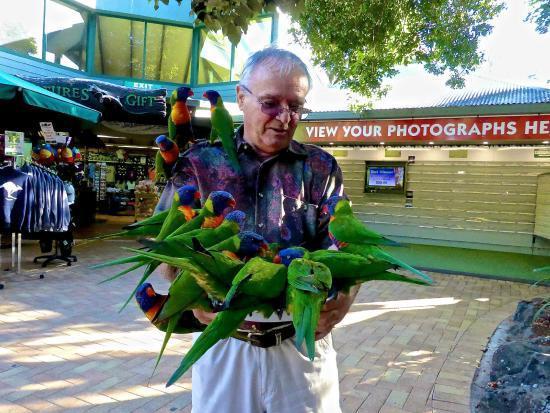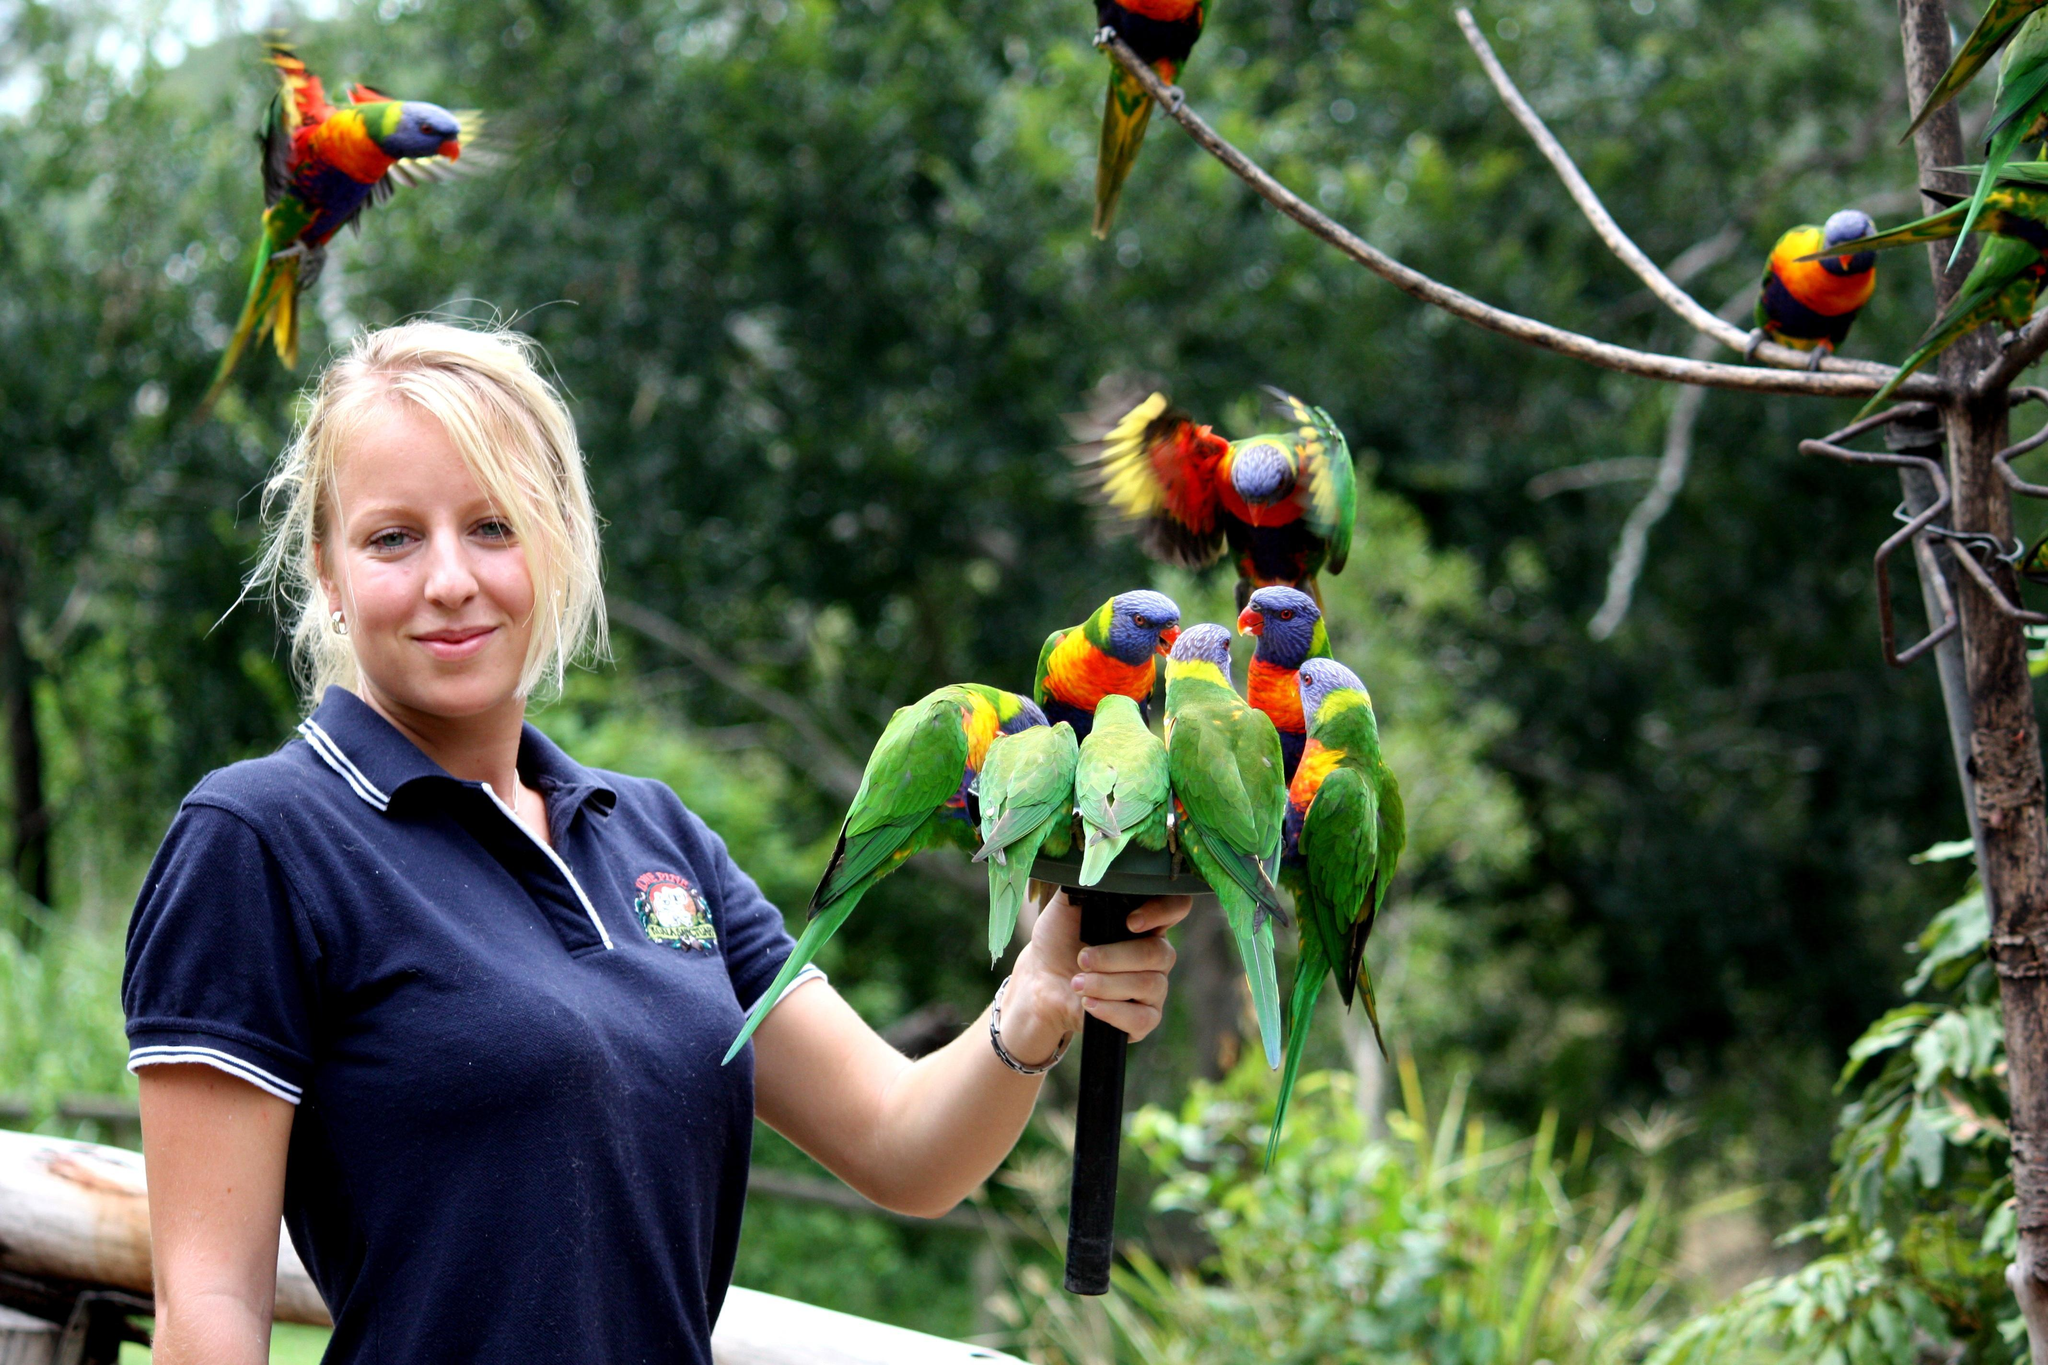The first image is the image on the left, the second image is the image on the right. Examine the images to the left and right. Is the description "There is one human feeding birds in every image." accurate? Answer yes or no. Yes. The first image is the image on the left, the second image is the image on the right. Examine the images to the left and right. Is the description "Birds are perched on a male in the image on the right and at least one female in the image on the left." accurate? Answer yes or no. No. 